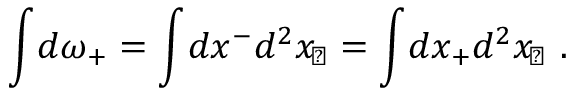<formula> <loc_0><loc_0><loc_500><loc_500>\int \, d \omega _ { + } = \int \, d x ^ { - } d ^ { 2 } x _ { \, \perp } = \int \, d x _ { + } d ^ { 2 } x _ { \, \perp } \ .</formula> 